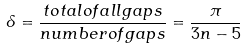Convert formula to latex. <formula><loc_0><loc_0><loc_500><loc_500>\delta = \frac { t o t a l o f a l l g a p s } { n u m b e r o f g a p s } = \frac { \pi } { 3 n - 5 }</formula> 